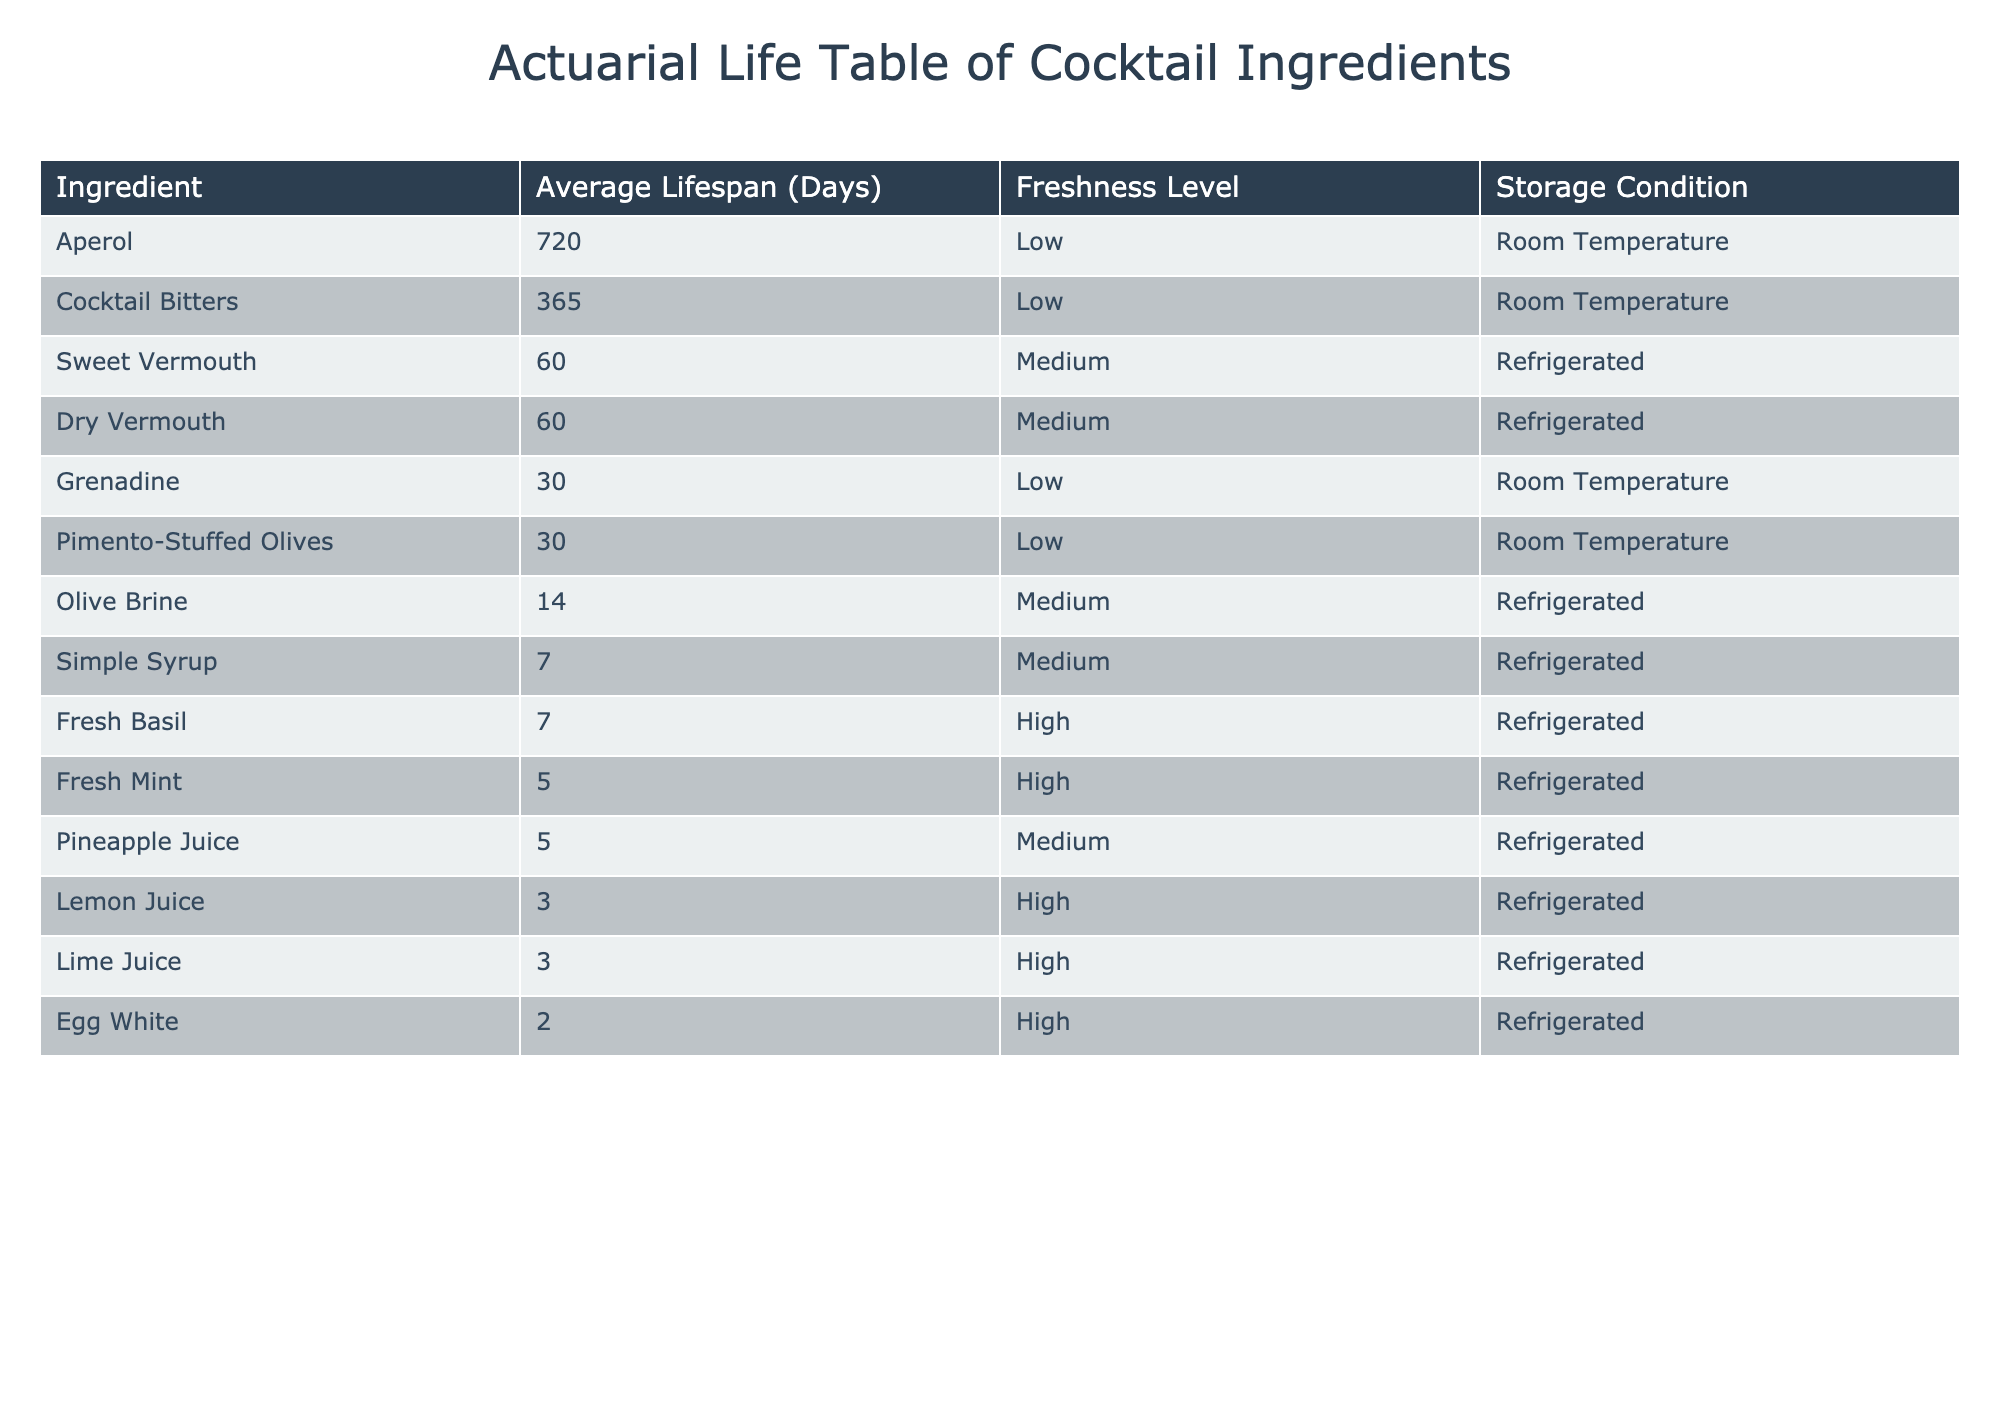What is the average lifespan of lemon juice? According to the table, the average lifespan of lemon juice is listed as 3 days.
Answer: 3 days Which ingredient has the longest average lifespan? By scanning the table for the ingredient with the highest average lifespan, we see that Aperol has an average lifespan of 720 days, which is the longest.
Answer: Aperol How many ingredients have a freshness level categorized as "High"? Reviewing the table, we count the ingredients with a freshness level marked as "High": Lemon Juice, Lime Juice, Fresh Mint, Fresh Basil, and Egg White, totaling five ingredients.
Answer: 5 Is olive brine stored under "Room Temperature"? The table indicates that olive brine is stored in "Refrigerated" conditions, not "Room Temperature."
Answer: No What is the total average lifespan of all "Medium" freshness level ingredients? In the table, the medium freshness ingredients are Simple Syrup (7 days), Pineapple Juice (5 days), Olive Brine (14 days), Sweet Vermouth (60 days), and Dry Vermouth (60 days). Adding these together yields 7 + 5 + 14 + 60 + 60 = 146 days. The total average lifespan for medium ingredients is therefore 146 days.
Answer: 146 days Are there any ingredients with an average lifespan of less than 5 days? A look through the table reveals that lemon juice, lime juice, and egg white all have lifespans shorter than 5 days, indicating that the statement is true.
Answer: Yes What is the freshness level of Pimento-Stuffed Olives? Referring to the table, Pimento-Stuffed Olives have a freshness level of "Low."
Answer: Low How many days does fresh mint last compared to simple syrup? Fresh Mint lasts for 5 days and Simple Syrup lasts for 7 days. The difference is calculated as 7 - 5 = 2 days, meaning Simple Syrup lasts 2 days longer than Fresh Mint.
Answer: 2 days longer Which ingredient has a shorter lifespan, fresh basil or cocktail bitters? From the table, fresh basil lasts for 7 days, while cocktail bitters last for 365 days. Since 7 days is less than 365 days, the answer is fresh basil.
Answer: Fresh basil 